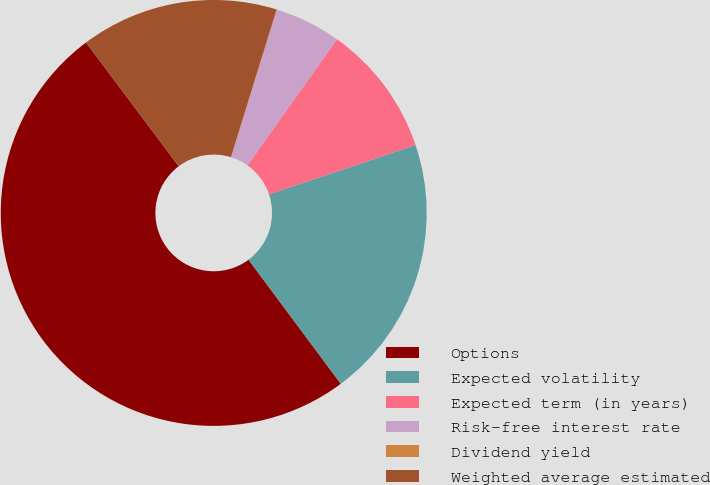<chart> <loc_0><loc_0><loc_500><loc_500><pie_chart><fcel>Options<fcel>Expected volatility<fcel>Expected term (in years)<fcel>Risk-free interest rate<fcel>Dividend yield<fcel>Weighted average estimated<nl><fcel>49.94%<fcel>19.99%<fcel>10.01%<fcel>5.02%<fcel>0.03%<fcel>15.0%<nl></chart> 